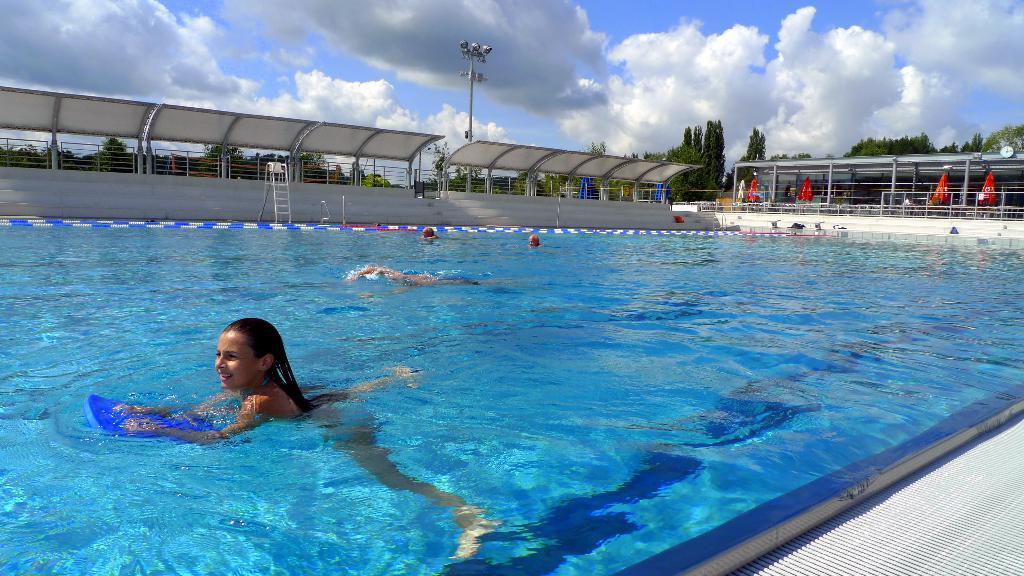Could you give a brief overview of what you see in this image? In the picture we can see group of people swimming in pool and there are some stairs, in the background of the picture there are some trees and sunny sky. 